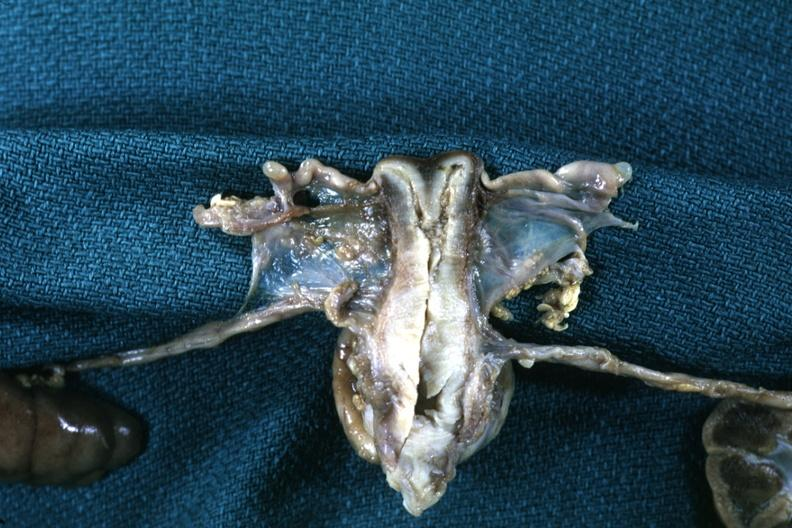s female reproductive present?
Answer the question using a single word or phrase. Yes 